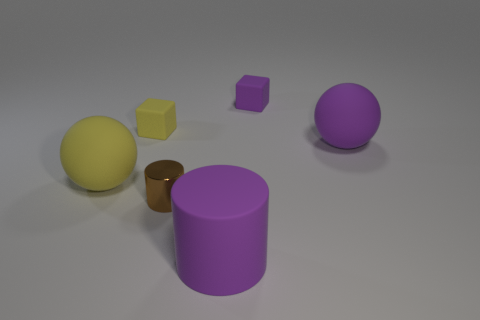The big cylinder that is made of the same material as the yellow block is what color?
Offer a terse response. Purple. Is there a yellow cylinder that has the same size as the purple matte cylinder?
Offer a very short reply. No. There is another purple object that is the same shape as the small shiny object; what is it made of?
Offer a very short reply. Rubber. What shape is the purple matte object that is the same size as the purple rubber cylinder?
Your response must be concise. Sphere. Are there any large matte things of the same shape as the small yellow matte thing?
Give a very brief answer. No. There is a object that is behind the yellow matte cube behind the large purple matte ball; what is its shape?
Make the answer very short. Cube. The tiny purple thing has what shape?
Give a very brief answer. Cube. What is the big sphere that is to the left of the big purple matte thing that is to the left of the tiny rubber block on the right side of the yellow matte cube made of?
Provide a succinct answer. Rubber. How many other objects are the same material as the big yellow object?
Ensure brevity in your answer.  4. There is a yellow matte object on the left side of the yellow block; what number of small yellow things are in front of it?
Provide a short and direct response. 0. 